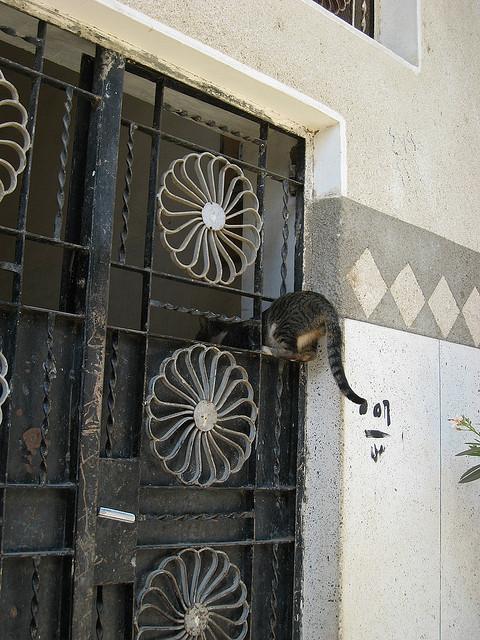Where's the smiley face?
Short answer required. Wall. What is the door made of?
Give a very brief answer. Metal. Do you think the cat tore the screen to get out?
Be succinct. No. What animal is in this picture?
Be succinct. Cat. 